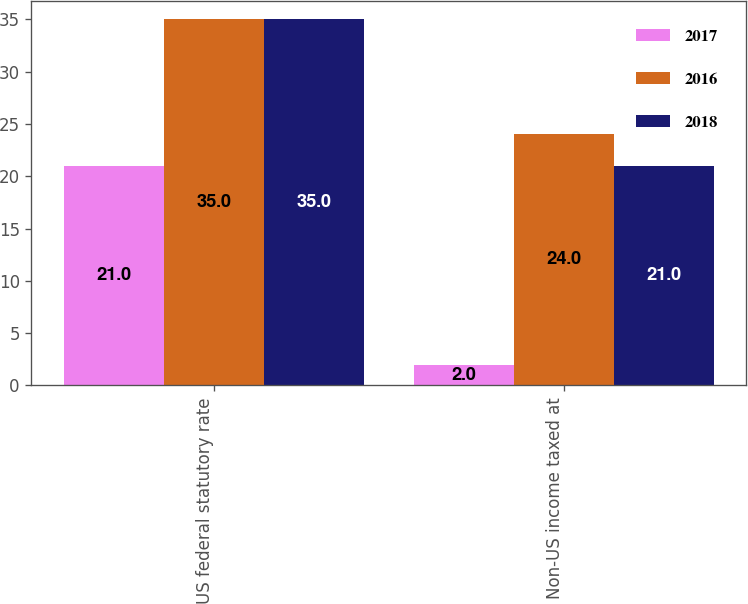Convert chart to OTSL. <chart><loc_0><loc_0><loc_500><loc_500><stacked_bar_chart><ecel><fcel>US federal statutory rate<fcel>Non-US income taxed at<nl><fcel>2017<fcel>21<fcel>2<nl><fcel>2016<fcel>35<fcel>24<nl><fcel>2018<fcel>35<fcel>21<nl></chart> 